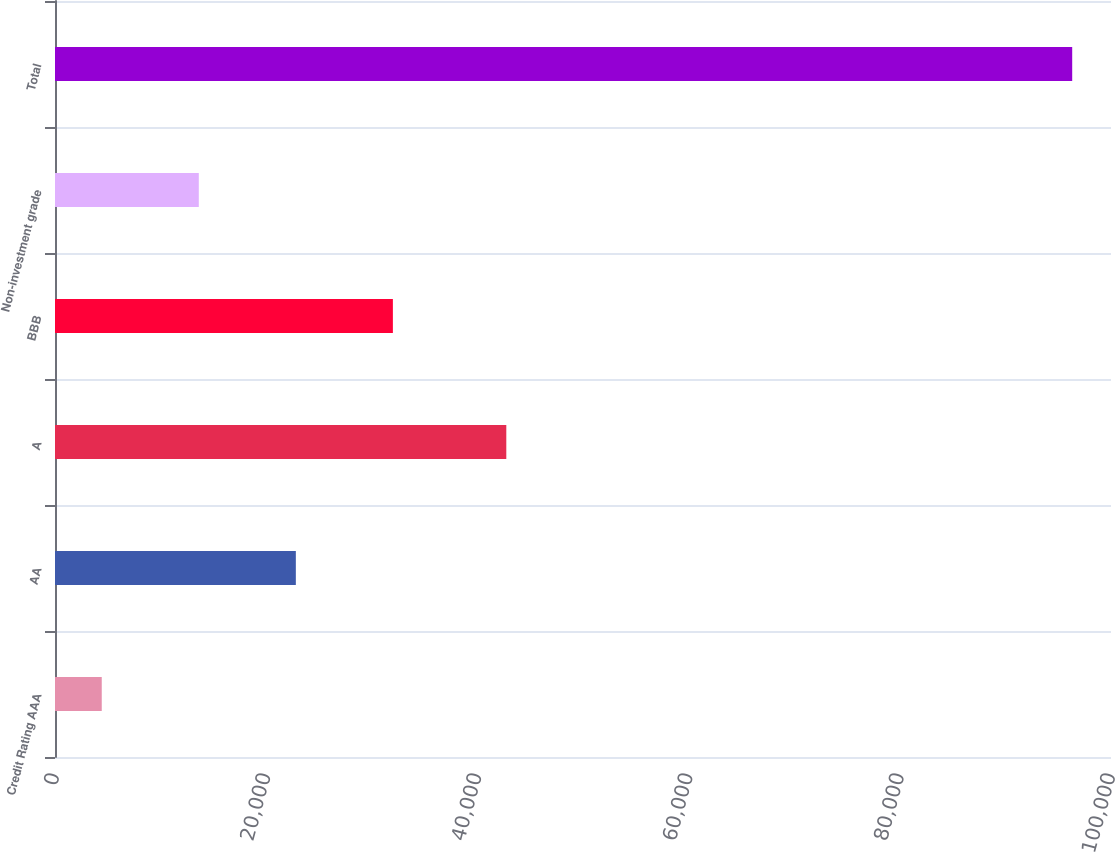Convert chart. <chart><loc_0><loc_0><loc_500><loc_500><bar_chart><fcel>Credit Rating AAA<fcel>AA<fcel>A<fcel>BBB<fcel>Non-investment grade<fcel>Total<nl><fcel>4427<fcel>22806.8<fcel>42737<fcel>31996.7<fcel>13616.9<fcel>96326<nl></chart> 